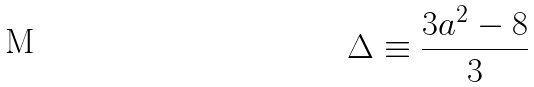Convert formula to latex. <formula><loc_0><loc_0><loc_500><loc_500>\Delta \equiv \frac { 3 a ^ { 2 } - 8 } { 3 }</formula> 